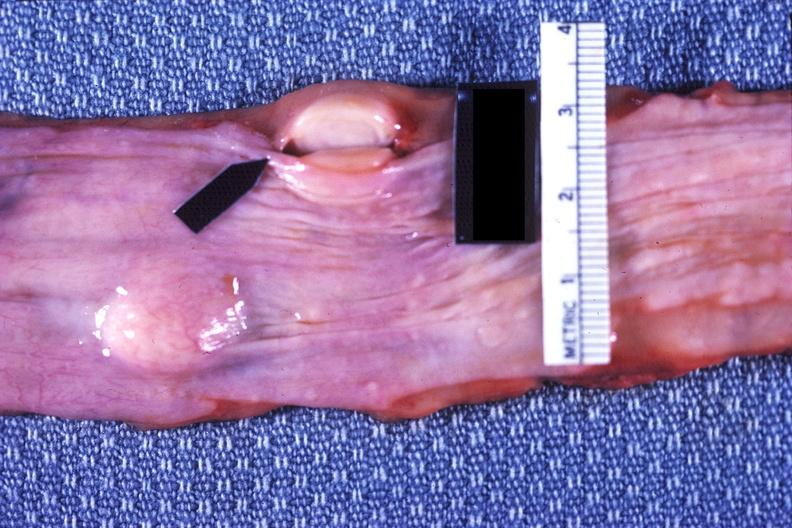s gastrointestinal present?
Answer the question using a single word or phrase. Yes 